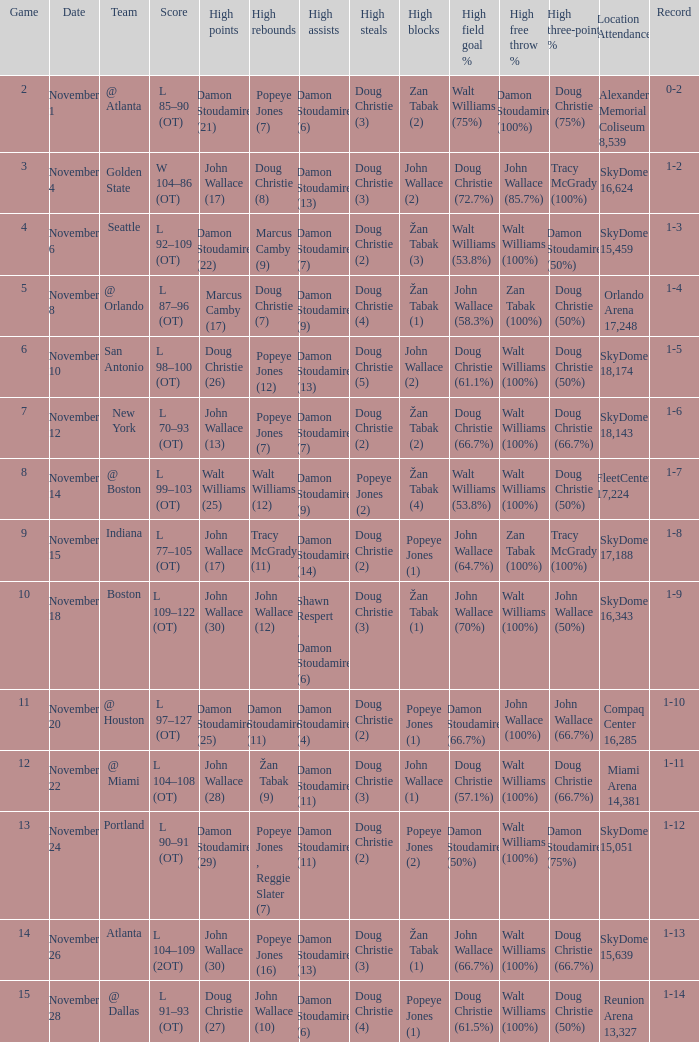What was the score against san antonio? L 98–100 (OT). 